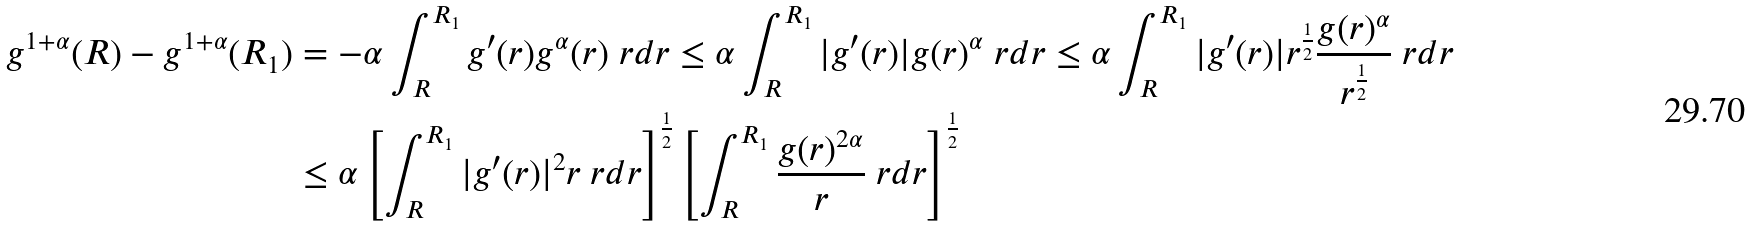Convert formula to latex. <formula><loc_0><loc_0><loc_500><loc_500>g ^ { 1 + \alpha } ( R ) - g ^ { 1 + \alpha } ( R _ { 1 } ) & = - \alpha \int _ { R } ^ { R _ { 1 } } g ^ { \prime } ( r ) g ^ { \alpha } ( r ) \ r d r \leq \alpha \int _ { R } ^ { R _ { 1 } } | g ^ { \prime } ( r ) | g ( r ) ^ { \alpha } \ r d r \leq \alpha \int _ { R } ^ { R _ { 1 } } | g ^ { \prime } ( r ) | r ^ { \frac { 1 } { 2 } } \frac { g ( r ) ^ { \alpha } } { r ^ { \frac { 1 } { 2 } } } \ r d r \\ & \leq \alpha \left [ \int _ { R } ^ { R _ { 1 } } | g ^ { \prime } ( r ) | ^ { 2 } r \ r d r \right ] ^ { \frac { 1 } { 2 } } \left [ \int _ { R } ^ { R _ { 1 } } \frac { g ( r ) ^ { 2 \alpha } } { r } \ r d r \right ] ^ { \frac { 1 } { 2 } }</formula> 